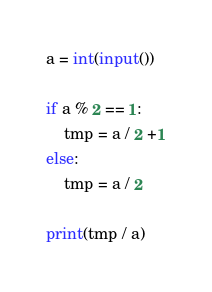<code> <loc_0><loc_0><loc_500><loc_500><_Python_>a = int(input())

if a % 2 == 1:
	tmp = a / 2 +1
else:
	tmp = a / 2 

print(tmp / a)</code> 